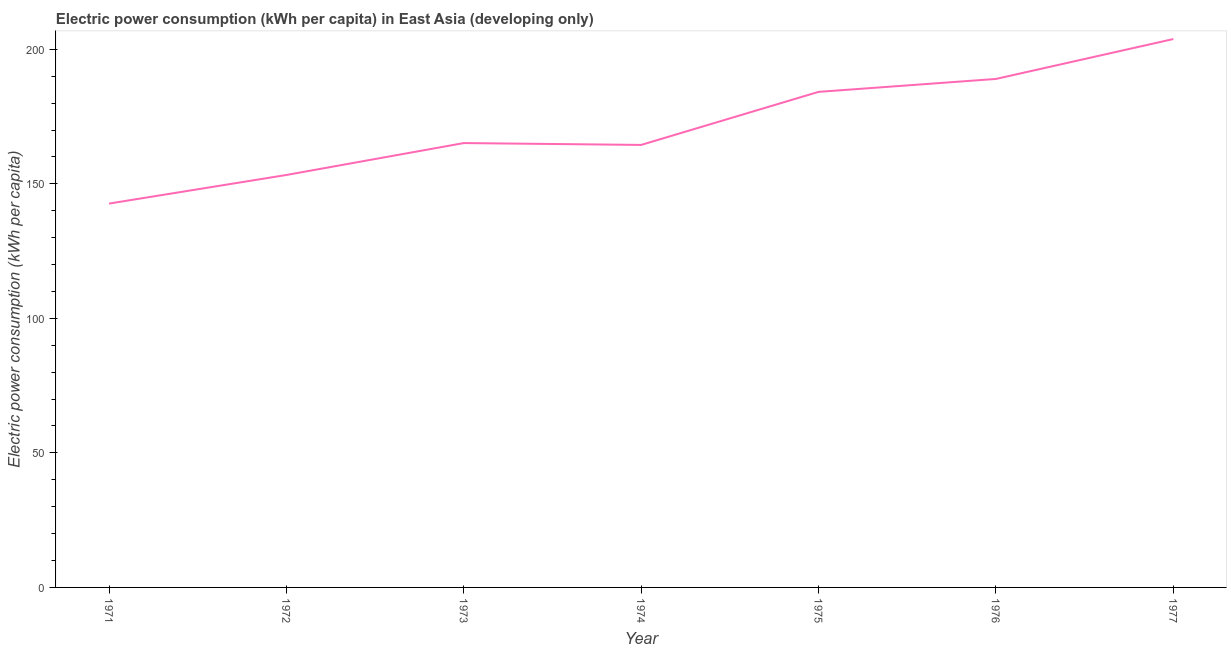What is the electric power consumption in 1977?
Ensure brevity in your answer.  203.8. Across all years, what is the maximum electric power consumption?
Make the answer very short. 203.8. Across all years, what is the minimum electric power consumption?
Make the answer very short. 142.65. In which year was the electric power consumption maximum?
Give a very brief answer. 1977. In which year was the electric power consumption minimum?
Provide a short and direct response. 1971. What is the sum of the electric power consumption?
Provide a succinct answer. 1202.49. What is the difference between the electric power consumption in 1976 and 1977?
Make the answer very short. -14.83. What is the average electric power consumption per year?
Your answer should be very brief. 171.78. What is the median electric power consumption?
Your answer should be compact. 165.15. In how many years, is the electric power consumption greater than 10 kWh per capita?
Provide a short and direct response. 7. Do a majority of the years between 1972 and 1976 (inclusive) have electric power consumption greater than 10 kWh per capita?
Your response must be concise. Yes. What is the ratio of the electric power consumption in 1974 to that in 1976?
Your answer should be compact. 0.87. What is the difference between the highest and the second highest electric power consumption?
Your response must be concise. 14.83. What is the difference between the highest and the lowest electric power consumption?
Make the answer very short. 61.15. Does the electric power consumption monotonically increase over the years?
Your answer should be very brief. No. How many lines are there?
Your answer should be very brief. 1. Are the values on the major ticks of Y-axis written in scientific E-notation?
Offer a terse response. No. Does the graph contain any zero values?
Provide a succinct answer. No. What is the title of the graph?
Your answer should be compact. Electric power consumption (kWh per capita) in East Asia (developing only). What is the label or title of the Y-axis?
Your answer should be very brief. Electric power consumption (kWh per capita). What is the Electric power consumption (kWh per capita) in 1971?
Provide a succinct answer. 142.65. What is the Electric power consumption (kWh per capita) in 1972?
Make the answer very short. 153.29. What is the Electric power consumption (kWh per capita) of 1973?
Offer a very short reply. 165.15. What is the Electric power consumption (kWh per capita) of 1974?
Offer a terse response. 164.46. What is the Electric power consumption (kWh per capita) in 1975?
Your answer should be very brief. 184.17. What is the Electric power consumption (kWh per capita) in 1976?
Offer a very short reply. 188.98. What is the Electric power consumption (kWh per capita) of 1977?
Your response must be concise. 203.8. What is the difference between the Electric power consumption (kWh per capita) in 1971 and 1972?
Provide a short and direct response. -10.63. What is the difference between the Electric power consumption (kWh per capita) in 1971 and 1973?
Provide a short and direct response. -22.49. What is the difference between the Electric power consumption (kWh per capita) in 1971 and 1974?
Make the answer very short. -21.8. What is the difference between the Electric power consumption (kWh per capita) in 1971 and 1975?
Make the answer very short. -41.52. What is the difference between the Electric power consumption (kWh per capita) in 1971 and 1976?
Provide a short and direct response. -46.32. What is the difference between the Electric power consumption (kWh per capita) in 1971 and 1977?
Give a very brief answer. -61.15. What is the difference between the Electric power consumption (kWh per capita) in 1972 and 1973?
Your response must be concise. -11.86. What is the difference between the Electric power consumption (kWh per capita) in 1972 and 1974?
Make the answer very short. -11.17. What is the difference between the Electric power consumption (kWh per capita) in 1972 and 1975?
Your response must be concise. -30.88. What is the difference between the Electric power consumption (kWh per capita) in 1972 and 1976?
Provide a succinct answer. -35.69. What is the difference between the Electric power consumption (kWh per capita) in 1972 and 1977?
Provide a succinct answer. -50.51. What is the difference between the Electric power consumption (kWh per capita) in 1973 and 1974?
Provide a succinct answer. 0.69. What is the difference between the Electric power consumption (kWh per capita) in 1973 and 1975?
Your response must be concise. -19.03. What is the difference between the Electric power consumption (kWh per capita) in 1973 and 1976?
Your response must be concise. -23.83. What is the difference between the Electric power consumption (kWh per capita) in 1973 and 1977?
Your response must be concise. -38.65. What is the difference between the Electric power consumption (kWh per capita) in 1974 and 1975?
Your response must be concise. -19.72. What is the difference between the Electric power consumption (kWh per capita) in 1974 and 1976?
Provide a succinct answer. -24.52. What is the difference between the Electric power consumption (kWh per capita) in 1974 and 1977?
Offer a very short reply. -39.34. What is the difference between the Electric power consumption (kWh per capita) in 1975 and 1976?
Provide a short and direct response. -4.8. What is the difference between the Electric power consumption (kWh per capita) in 1975 and 1977?
Your answer should be compact. -19.63. What is the difference between the Electric power consumption (kWh per capita) in 1976 and 1977?
Offer a very short reply. -14.83. What is the ratio of the Electric power consumption (kWh per capita) in 1971 to that in 1973?
Your answer should be compact. 0.86. What is the ratio of the Electric power consumption (kWh per capita) in 1971 to that in 1974?
Provide a succinct answer. 0.87. What is the ratio of the Electric power consumption (kWh per capita) in 1971 to that in 1975?
Provide a succinct answer. 0.78. What is the ratio of the Electric power consumption (kWh per capita) in 1971 to that in 1976?
Provide a succinct answer. 0.76. What is the ratio of the Electric power consumption (kWh per capita) in 1972 to that in 1973?
Make the answer very short. 0.93. What is the ratio of the Electric power consumption (kWh per capita) in 1972 to that in 1974?
Your answer should be compact. 0.93. What is the ratio of the Electric power consumption (kWh per capita) in 1972 to that in 1975?
Give a very brief answer. 0.83. What is the ratio of the Electric power consumption (kWh per capita) in 1972 to that in 1976?
Ensure brevity in your answer.  0.81. What is the ratio of the Electric power consumption (kWh per capita) in 1972 to that in 1977?
Offer a terse response. 0.75. What is the ratio of the Electric power consumption (kWh per capita) in 1973 to that in 1974?
Offer a very short reply. 1. What is the ratio of the Electric power consumption (kWh per capita) in 1973 to that in 1975?
Provide a short and direct response. 0.9. What is the ratio of the Electric power consumption (kWh per capita) in 1973 to that in 1976?
Give a very brief answer. 0.87. What is the ratio of the Electric power consumption (kWh per capita) in 1973 to that in 1977?
Give a very brief answer. 0.81. What is the ratio of the Electric power consumption (kWh per capita) in 1974 to that in 1975?
Offer a terse response. 0.89. What is the ratio of the Electric power consumption (kWh per capita) in 1974 to that in 1976?
Give a very brief answer. 0.87. What is the ratio of the Electric power consumption (kWh per capita) in 1974 to that in 1977?
Offer a very short reply. 0.81. What is the ratio of the Electric power consumption (kWh per capita) in 1975 to that in 1977?
Provide a succinct answer. 0.9. What is the ratio of the Electric power consumption (kWh per capita) in 1976 to that in 1977?
Ensure brevity in your answer.  0.93. 